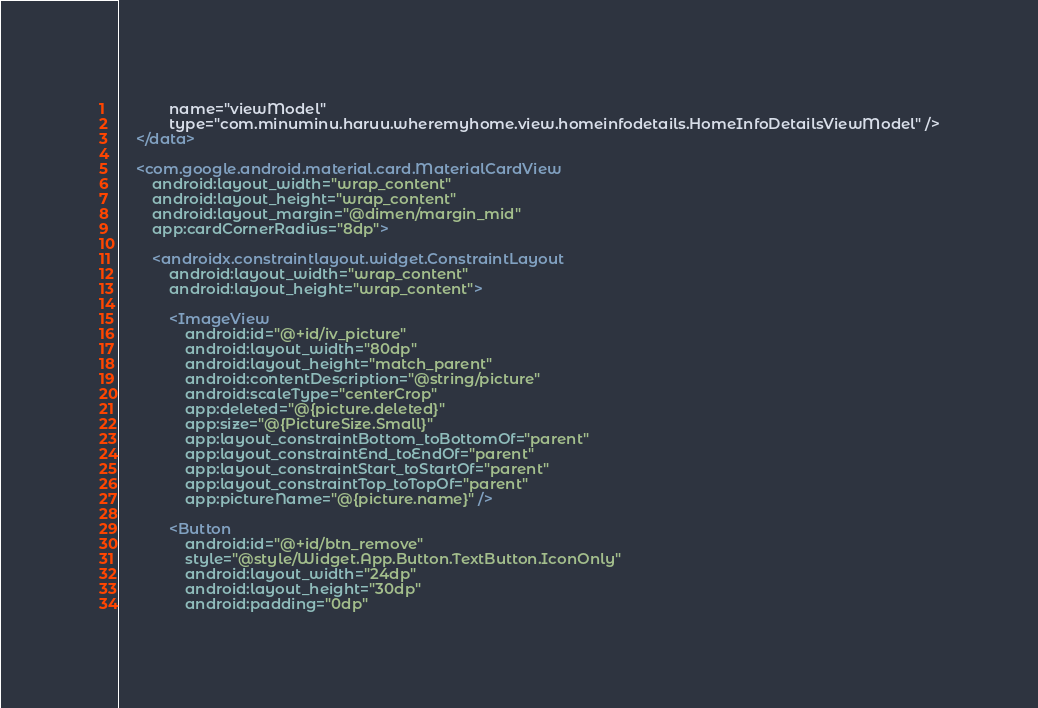Convert code to text. <code><loc_0><loc_0><loc_500><loc_500><_XML_>            name="viewModel"
            type="com.minuminu.haruu.wheremyhome.view.homeinfodetails.HomeInfoDetailsViewModel" />
    </data>

    <com.google.android.material.card.MaterialCardView
        android:layout_width="wrap_content"
        android:layout_height="wrap_content"
        android:layout_margin="@dimen/margin_mid"
        app:cardCornerRadius="8dp">

        <androidx.constraintlayout.widget.ConstraintLayout
            android:layout_width="wrap_content"
            android:layout_height="wrap_content">

            <ImageView
                android:id="@+id/iv_picture"
                android:layout_width="80dp"
                android:layout_height="match_parent"
                android:contentDescription="@string/picture"
                android:scaleType="centerCrop"
                app:deleted="@{picture.deleted}"
                app:size="@{PictureSize.Small}"
                app:layout_constraintBottom_toBottomOf="parent"
                app:layout_constraintEnd_toEndOf="parent"
                app:layout_constraintStart_toStartOf="parent"
                app:layout_constraintTop_toTopOf="parent"
                app:pictureName="@{picture.name}" />

            <Button
                android:id="@+id/btn_remove"
                style="@style/Widget.App.Button.TextButton.IconOnly"
                android:layout_width="24dp"
                android:layout_height="30dp"
                android:padding="0dp"</code> 